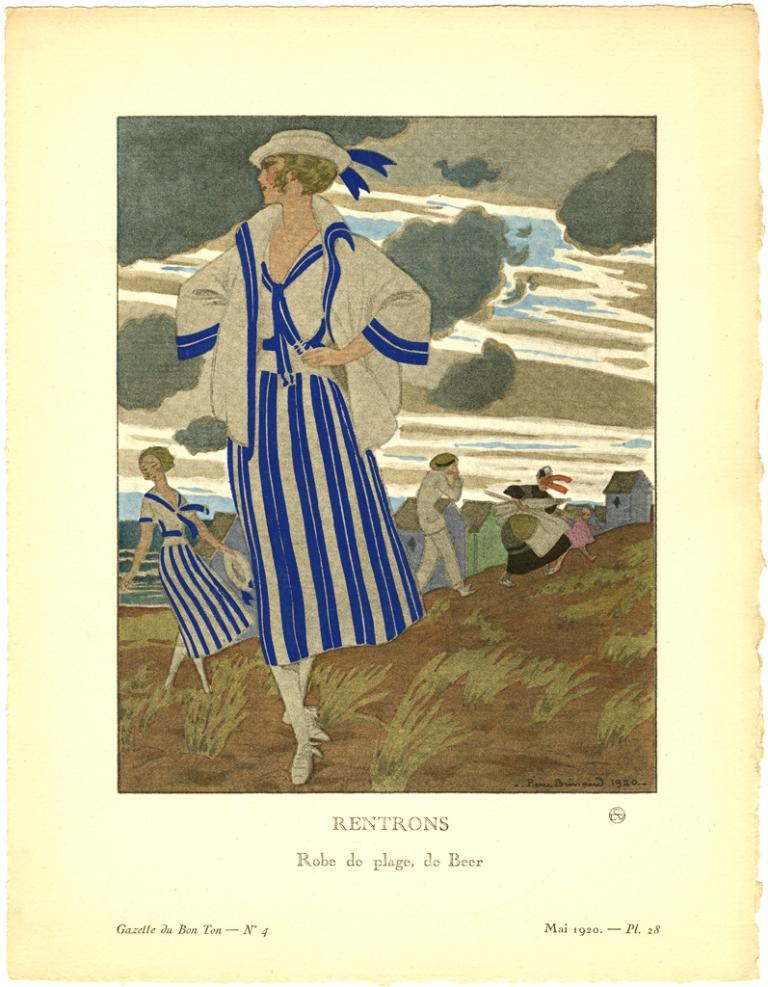What is the main subject of the image? The main subject of the image is a group of people on the ground. What structures can be seen in the image? There is a house in the image. What natural elements are present in the image? There is water and trees visible in the image. What type of terrain is depicted in the image? There are stones in the image, suggesting a rocky or stony terrain. What flavor of toothpaste is the giraffe using in the image? There is no giraffe or toothpaste present in the image. 